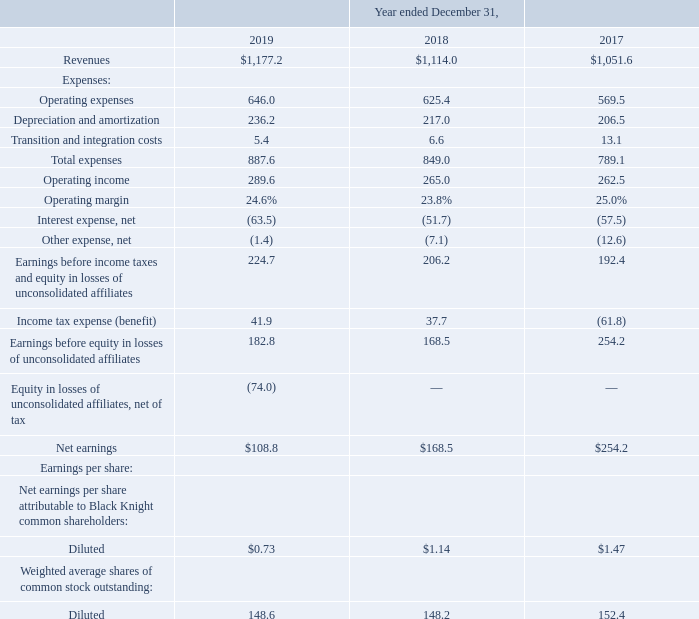Results of Operations
Consolidated Results of Operations
The following tables present certain financial data for the periods indicated (dollars in millions):
What was the revenue in 2019?
Answer scale should be: million. 1,177.2. What were the total expenses in 2018?
Answer scale should be: million. 849.0. What was the net interest expense in 2017?
Answer scale should be: million. (57.5). What was the change in operating income between 2017 and 2018?
Answer scale should be: million. 265.0-262.5
Answer: 2.5. How many years did the operating margin exceed 20.0%? 2019##2018##2017
Answer: 3. What was the change in net earnings between 2018 and 2019?
Answer scale should be: percent. (108.8-168.5)/168.5
Answer: -35.43. 